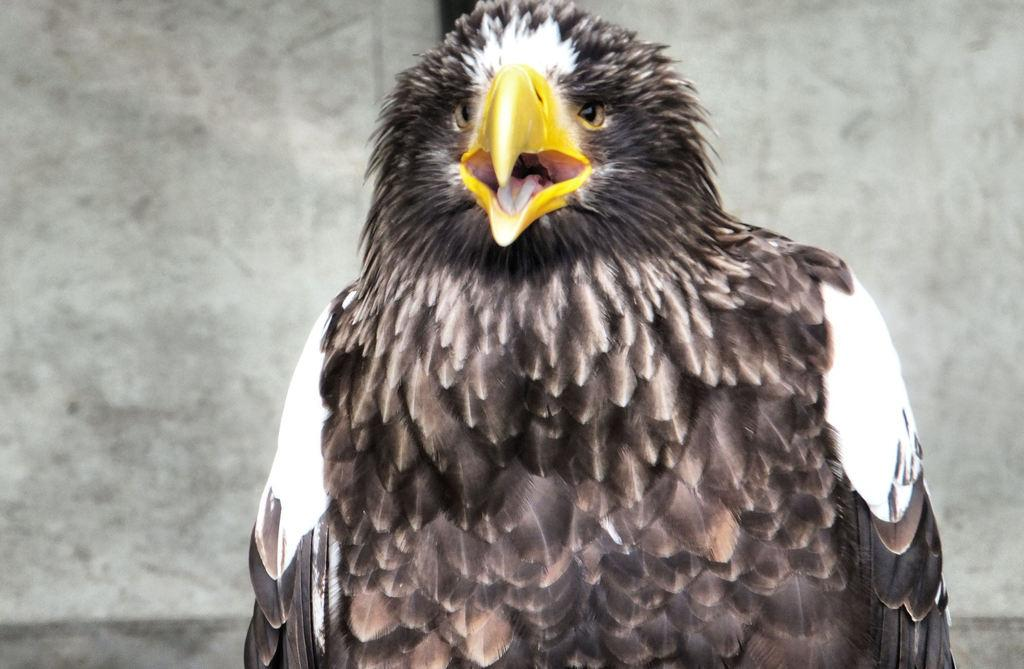What is the main subject of the image? There is a bird in the center of the image. Can you describe the bird's appearance? The bird has multi-color features. What can be seen in the background of the image? There is a wall in the background of the image. Are there any bears visible in the image? No, there are no bears present in the image. The image features a bird with multi-color features and a wall in the background. 